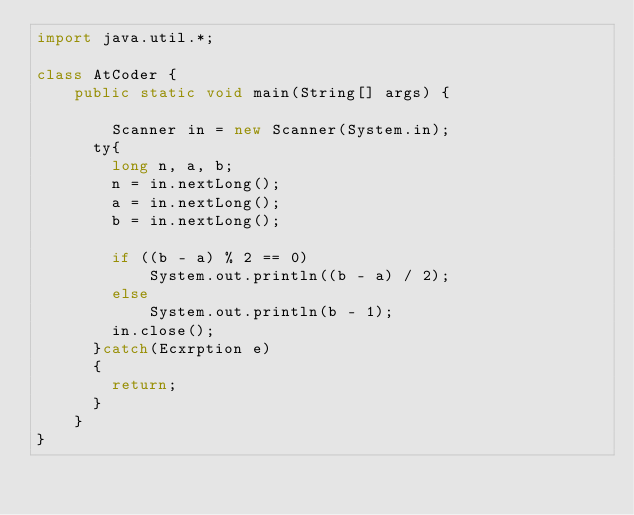Convert code to text. <code><loc_0><loc_0><loc_500><loc_500><_Java_>import java.util.*;

class AtCoder {
    public static void main(String[] args) {

        Scanner in = new Scanner(System.in);
      ty{
        long n, a, b;
        n = in.nextLong();
        a = in.nextLong();
        b = in.nextLong();

        if ((b - a) % 2 == 0)
            System.out.println((b - a) / 2);
        else
            System.out.println(b - 1);
        in.close();
      }catch(Ecxrption e)
      {
        return;
      }
    }
}</code> 